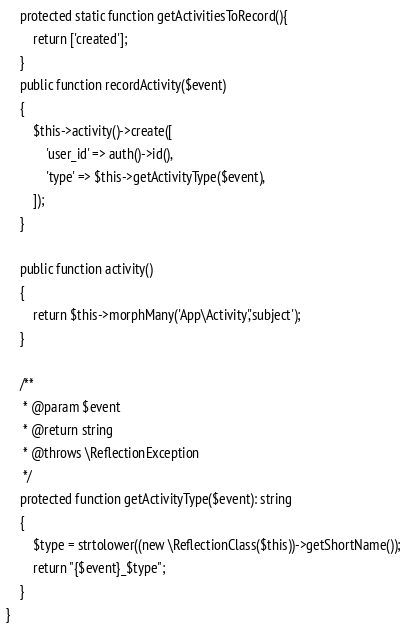<code> <loc_0><loc_0><loc_500><loc_500><_PHP_>
    protected static function getActivitiesToRecord(){
        return ['created'];
    }
    public function recordActivity($event)
    {
        $this->activity()->create([
            'user_id' => auth()->id(),
            'type' => $this->getActivityType($event),
        ]);
    }

    public function activity()
    {
        return $this->morphMany('App\Activity','subject');
    }

    /**
     * @param $event
     * @return string
     * @throws \ReflectionException
     */
    protected function getActivityType($event): string
    {
        $type = strtolower((new \ReflectionClass($this))->getShortName());
        return "{$event}_$type";
    }
}
</code> 